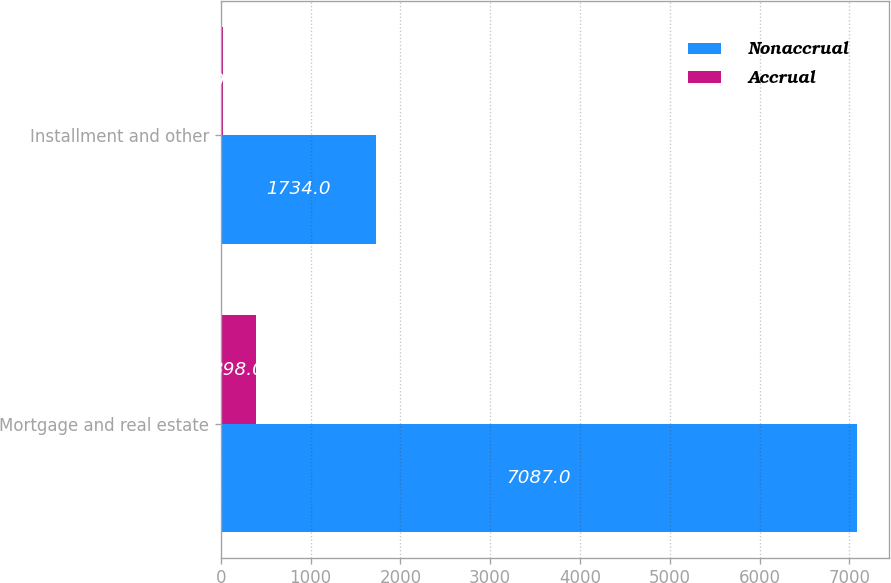Convert chart to OTSL. <chart><loc_0><loc_0><loc_500><loc_500><stacked_bar_chart><ecel><fcel>Mortgage and real estate<fcel>Installment and other<nl><fcel>Nonaccrual<fcel>7087<fcel>1734<nl><fcel>Accrual<fcel>398<fcel>29<nl></chart> 